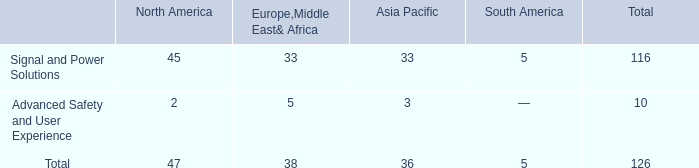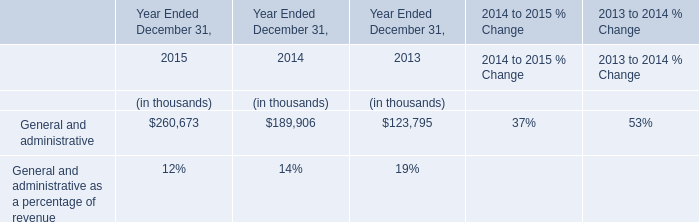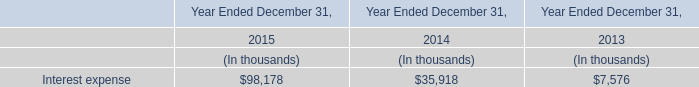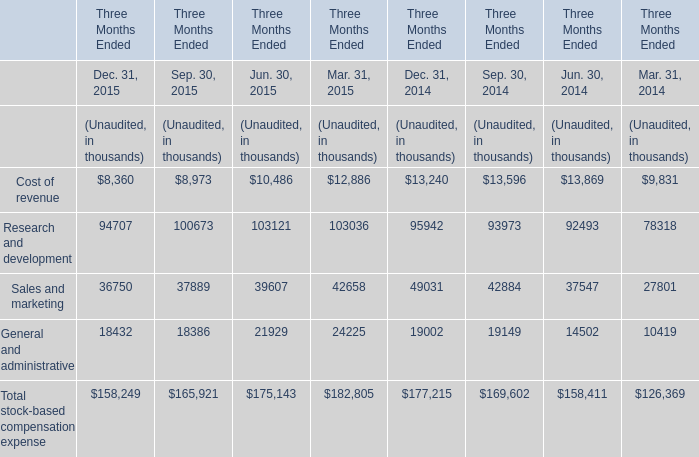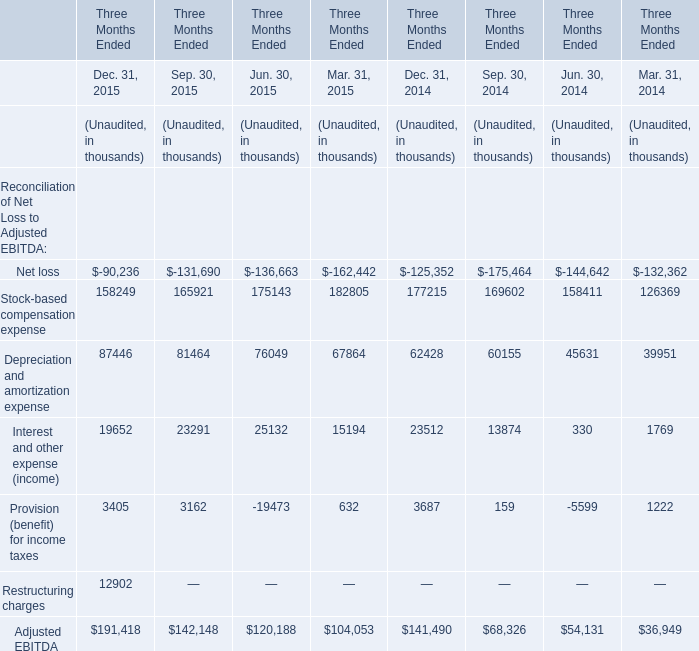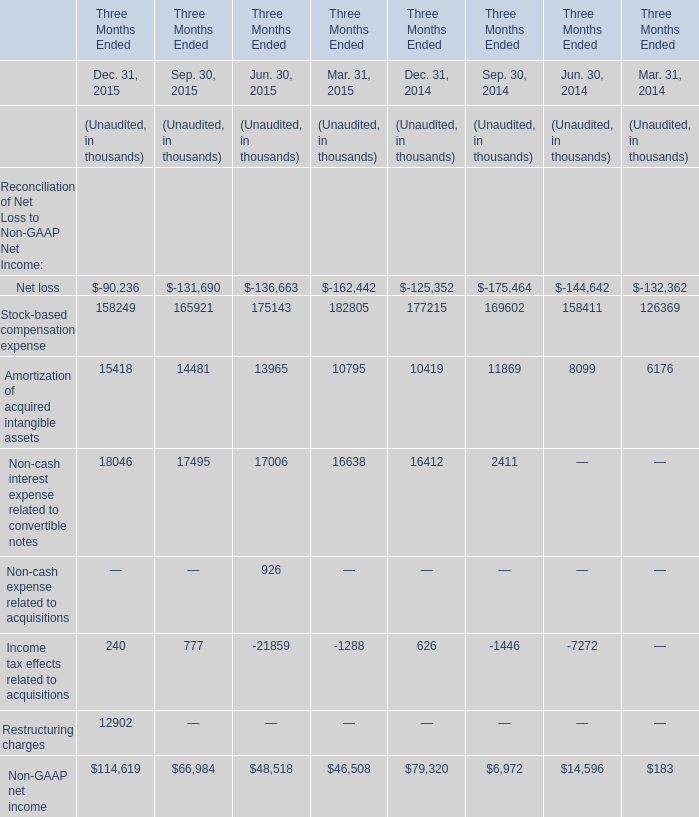Which year is Amortization of acquired intangible assets in the second quarter Unaudited higher? 
Answer: 2015. 